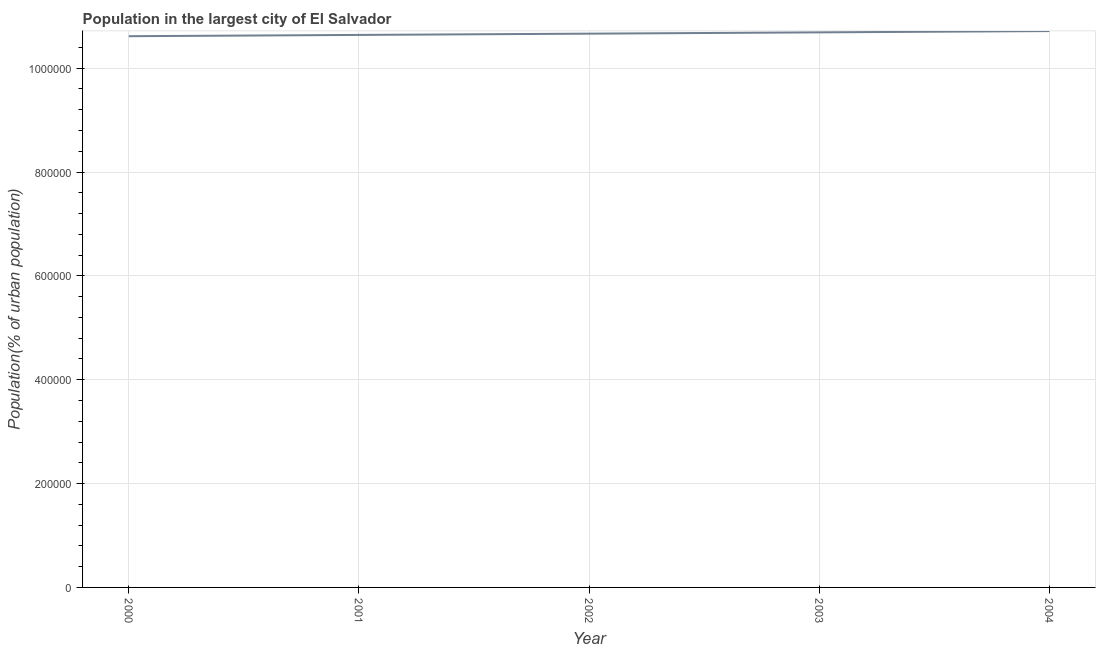What is the population in largest city in 2003?
Give a very brief answer. 1.07e+06. Across all years, what is the maximum population in largest city?
Your answer should be compact. 1.07e+06. Across all years, what is the minimum population in largest city?
Ensure brevity in your answer.  1.06e+06. In which year was the population in largest city maximum?
Your response must be concise. 2004. In which year was the population in largest city minimum?
Your answer should be very brief. 2000. What is the sum of the population in largest city?
Your response must be concise. 5.33e+06. What is the difference between the population in largest city in 2000 and 2002?
Your answer should be very brief. -4915. What is the average population in largest city per year?
Offer a terse response. 1.07e+06. What is the median population in largest city?
Keep it short and to the point. 1.07e+06. Do a majority of the years between 2000 and 2002 (inclusive) have population in largest city greater than 40000 %?
Provide a short and direct response. Yes. What is the ratio of the population in largest city in 2000 to that in 2004?
Offer a terse response. 0.99. What is the difference between the highest and the second highest population in largest city?
Keep it short and to the point. 2477. What is the difference between the highest and the lowest population in largest city?
Keep it short and to the point. 9860. In how many years, is the population in largest city greater than the average population in largest city taken over all years?
Provide a succinct answer. 2. How many lines are there?
Provide a succinct answer. 1. Does the graph contain any zero values?
Your answer should be compact. No. Does the graph contain grids?
Keep it short and to the point. Yes. What is the title of the graph?
Give a very brief answer. Population in the largest city of El Salvador. What is the label or title of the X-axis?
Make the answer very short. Year. What is the label or title of the Y-axis?
Offer a very short reply. Population(% of urban population). What is the Population(% of urban population) in 2000?
Your answer should be compact. 1.06e+06. What is the Population(% of urban population) of 2001?
Offer a very short reply. 1.06e+06. What is the Population(% of urban population) in 2002?
Keep it short and to the point. 1.07e+06. What is the Population(% of urban population) of 2003?
Your response must be concise. 1.07e+06. What is the Population(% of urban population) in 2004?
Your response must be concise. 1.07e+06. What is the difference between the Population(% of urban population) in 2000 and 2001?
Provide a succinct answer. -2453. What is the difference between the Population(% of urban population) in 2000 and 2002?
Ensure brevity in your answer.  -4915. What is the difference between the Population(% of urban population) in 2000 and 2003?
Give a very brief answer. -7383. What is the difference between the Population(% of urban population) in 2000 and 2004?
Make the answer very short. -9860. What is the difference between the Population(% of urban population) in 2001 and 2002?
Your answer should be compact. -2462. What is the difference between the Population(% of urban population) in 2001 and 2003?
Provide a short and direct response. -4930. What is the difference between the Population(% of urban population) in 2001 and 2004?
Provide a succinct answer. -7407. What is the difference between the Population(% of urban population) in 2002 and 2003?
Provide a short and direct response. -2468. What is the difference between the Population(% of urban population) in 2002 and 2004?
Your response must be concise. -4945. What is the difference between the Population(% of urban population) in 2003 and 2004?
Ensure brevity in your answer.  -2477. What is the ratio of the Population(% of urban population) in 2000 to that in 2002?
Keep it short and to the point. 0.99. What is the ratio of the Population(% of urban population) in 2000 to that in 2004?
Provide a short and direct response. 0.99. What is the ratio of the Population(% of urban population) in 2001 to that in 2002?
Your response must be concise. 1. What is the ratio of the Population(% of urban population) in 2001 to that in 2003?
Make the answer very short. 0.99. What is the ratio of the Population(% of urban population) in 2001 to that in 2004?
Offer a terse response. 0.99. What is the ratio of the Population(% of urban population) in 2003 to that in 2004?
Provide a short and direct response. 1. 